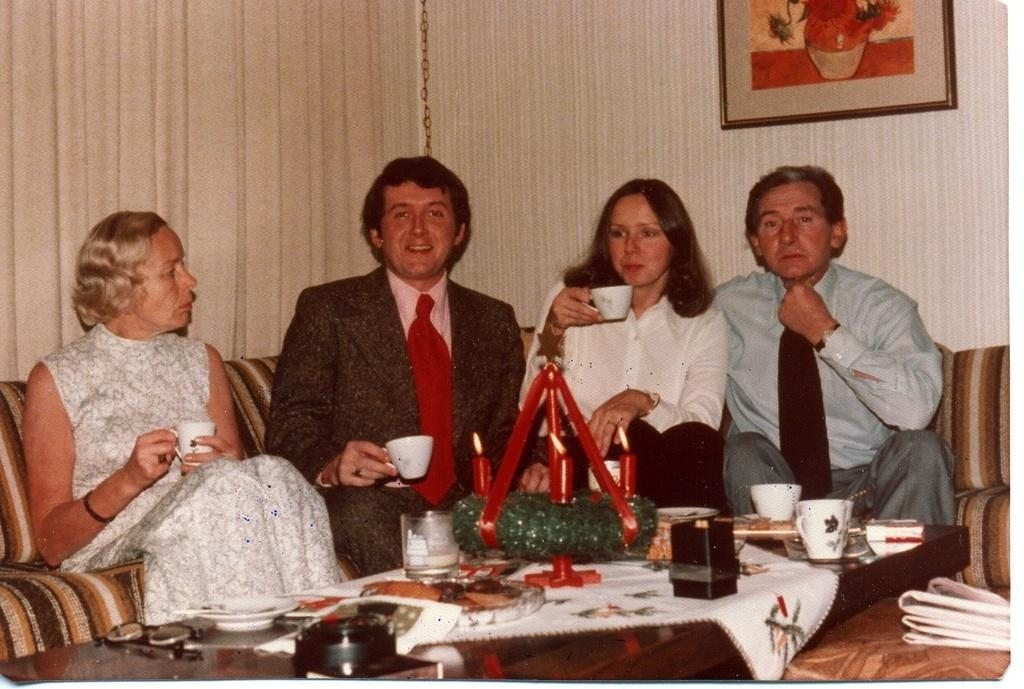How many people are present in the image? There are four people in the image. What are the people doing in the image? The people are sitting on a sofa. Are any of the people holding an object in their hands? Yes, three of the people are holding a cup in their hand. What type of stone is being twisted by one of the people in the image? There is no stone or twisting action present in the image. 